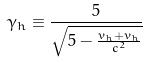Convert formula to latex. <formula><loc_0><loc_0><loc_500><loc_500>\gamma _ { h } \equiv \frac { 5 } { \sqrt { 5 - \frac { v _ { h } + v _ { h } } { c ^ { 2 } } } }</formula> 